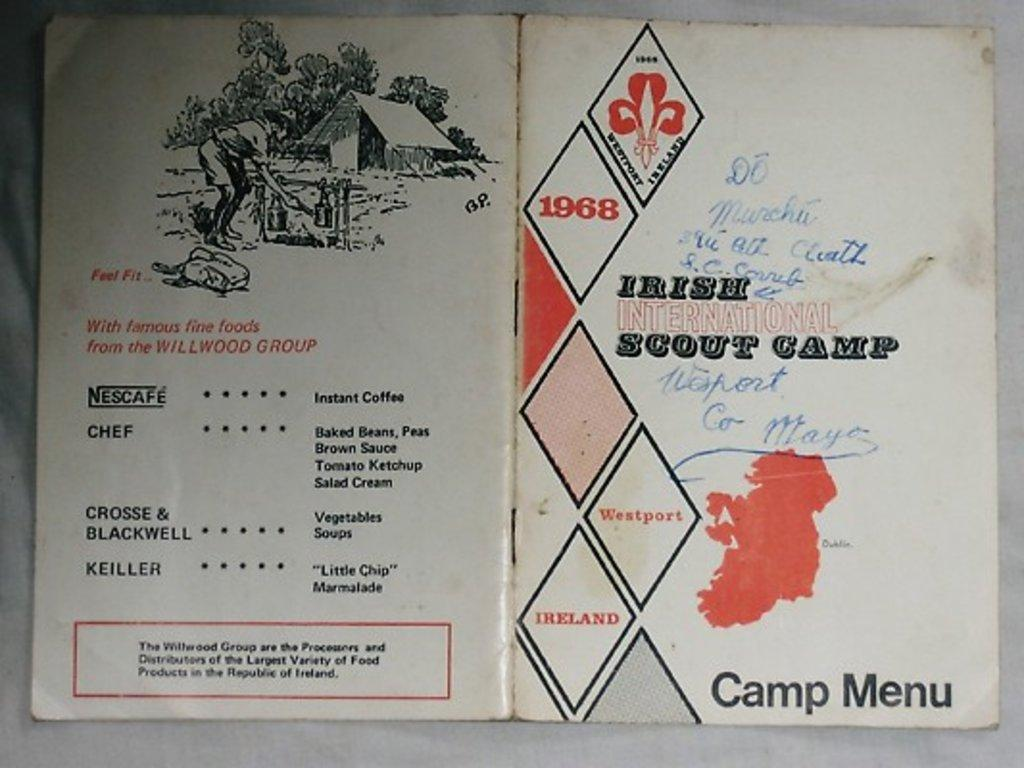<image>
Relay a brief, clear account of the picture shown. A booklet for Irish International Scout Camp's menu. 